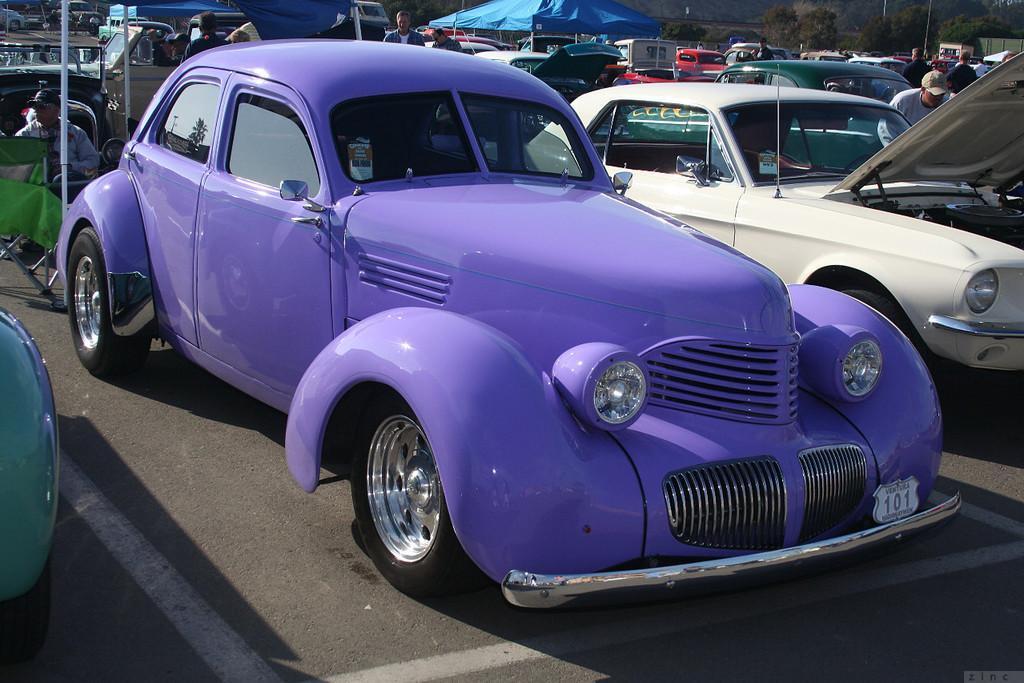In one or two sentences, can you explain what this image depicts? In this image, I can see different types of cars with different colors are parked. I can see few people standing. These are the canopy tents, which are blue in color. In the background, I can see the trees. Here is a person sitting on the chair. 